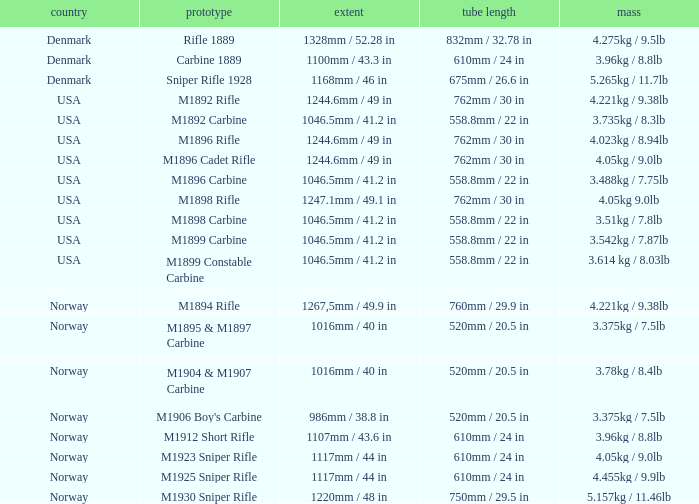What is Nation, when Model is M1895 & M1897 Carbine? Norway. 